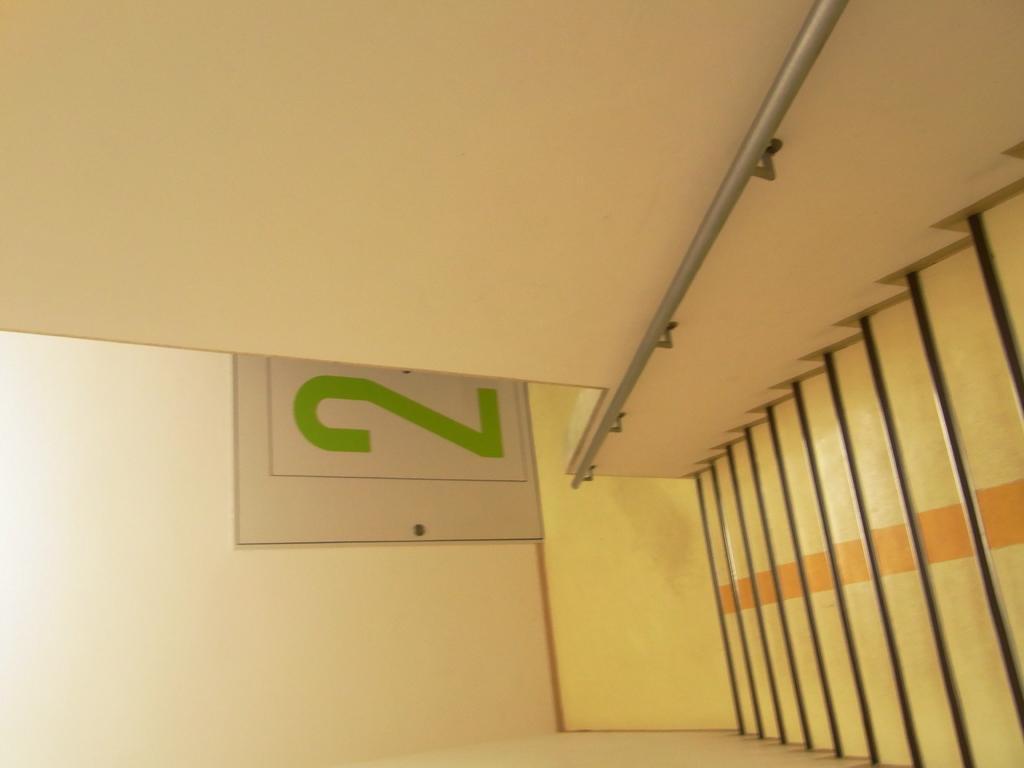Could you give a brief overview of what you see in this image? In this image, I can see a stair and a handrail to the wall. I can see a number on a board, which is attached to the wall. 